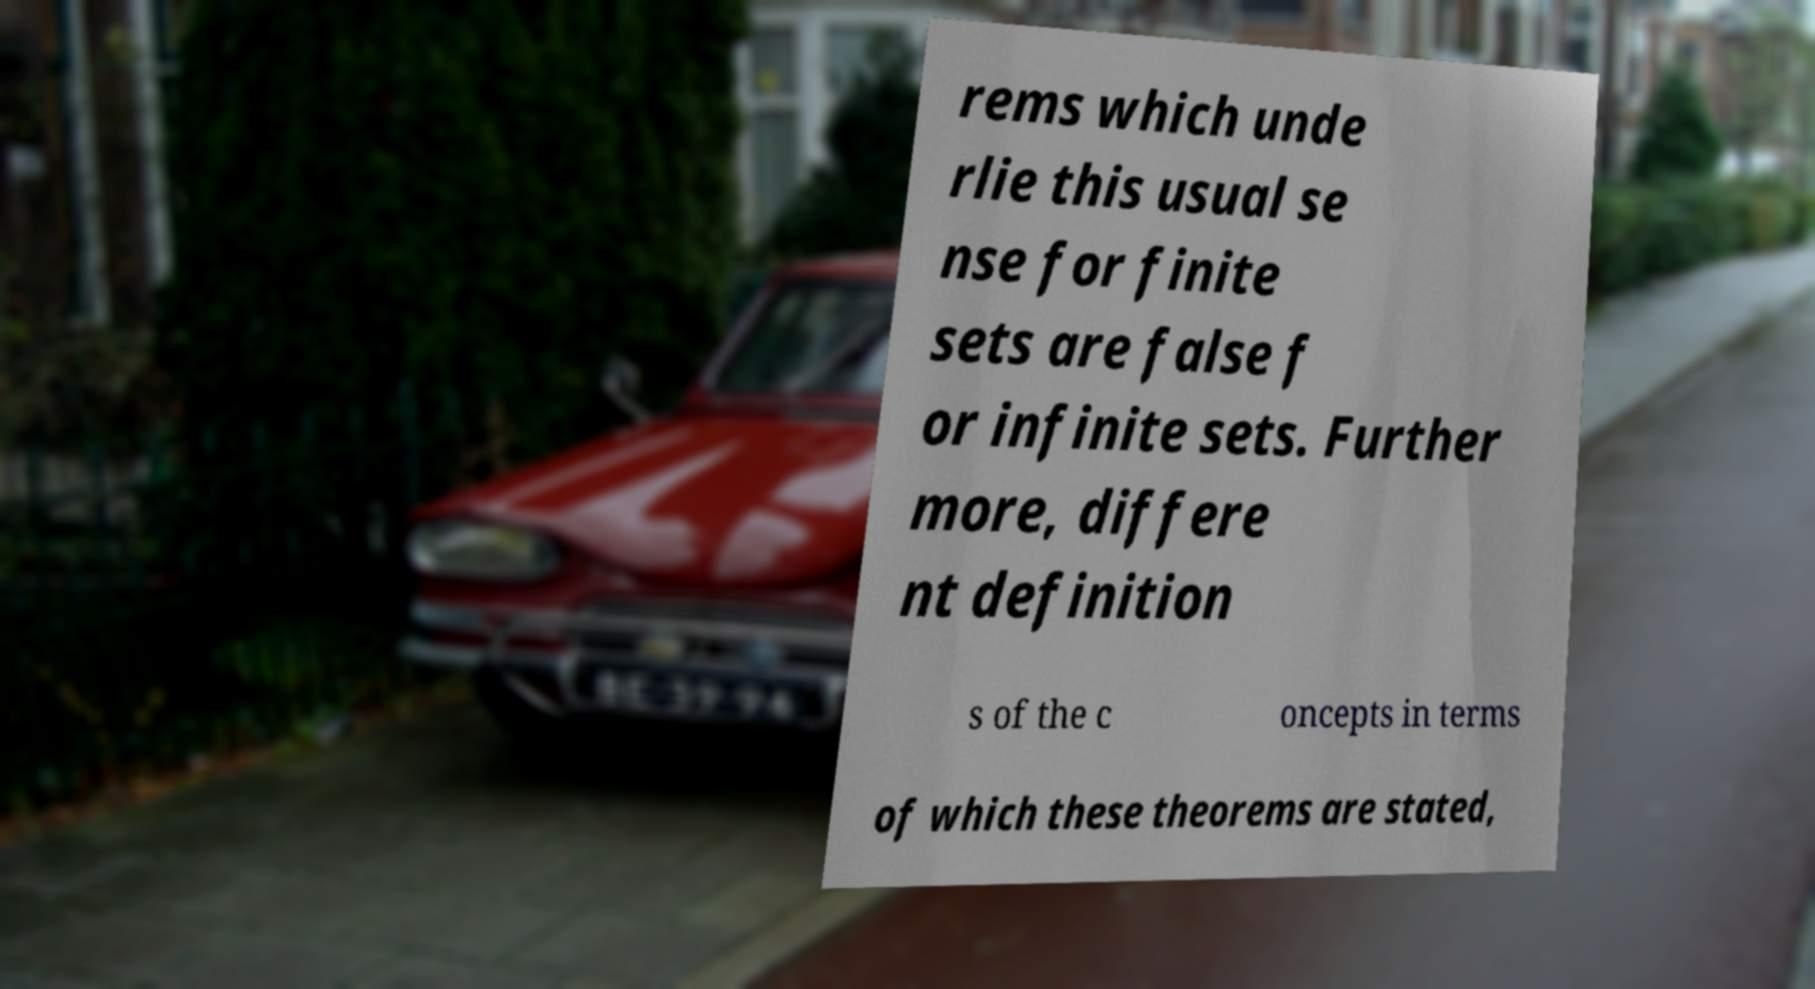Could you assist in decoding the text presented in this image and type it out clearly? rems which unde rlie this usual se nse for finite sets are false f or infinite sets. Further more, differe nt definition s of the c oncepts in terms of which these theorems are stated, 